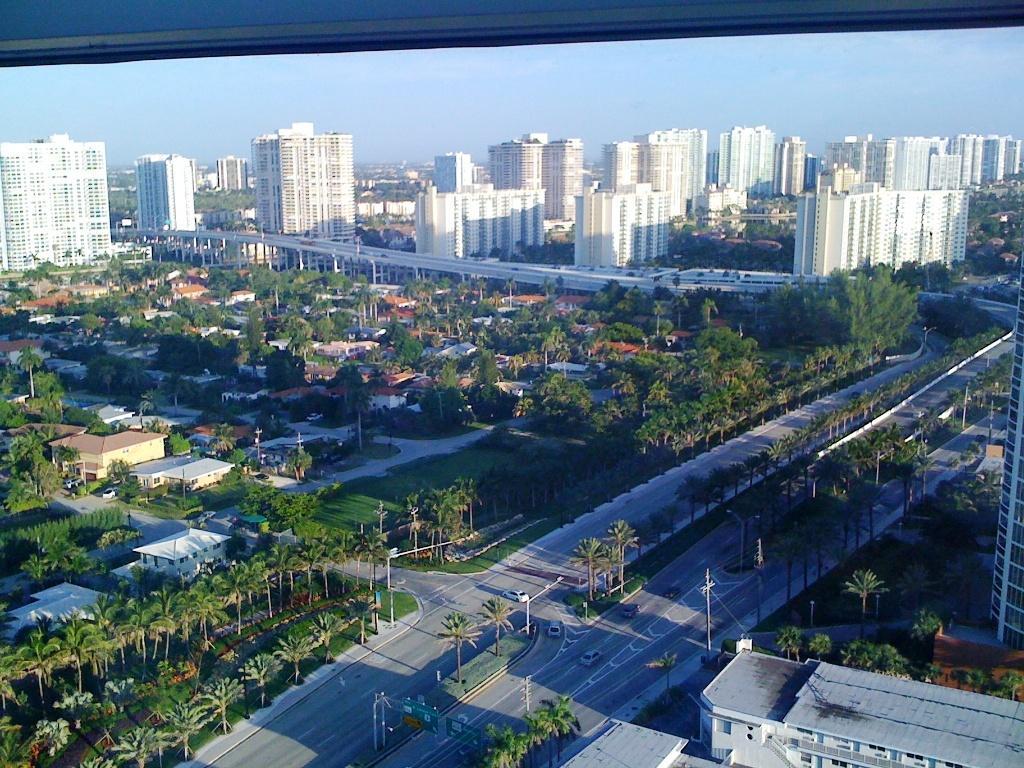Please provide a concise description of this image. In this image I can see trees in green color, buildings in white color. Background I can see sky in blue color and I can also see few electric poles and light poles. 